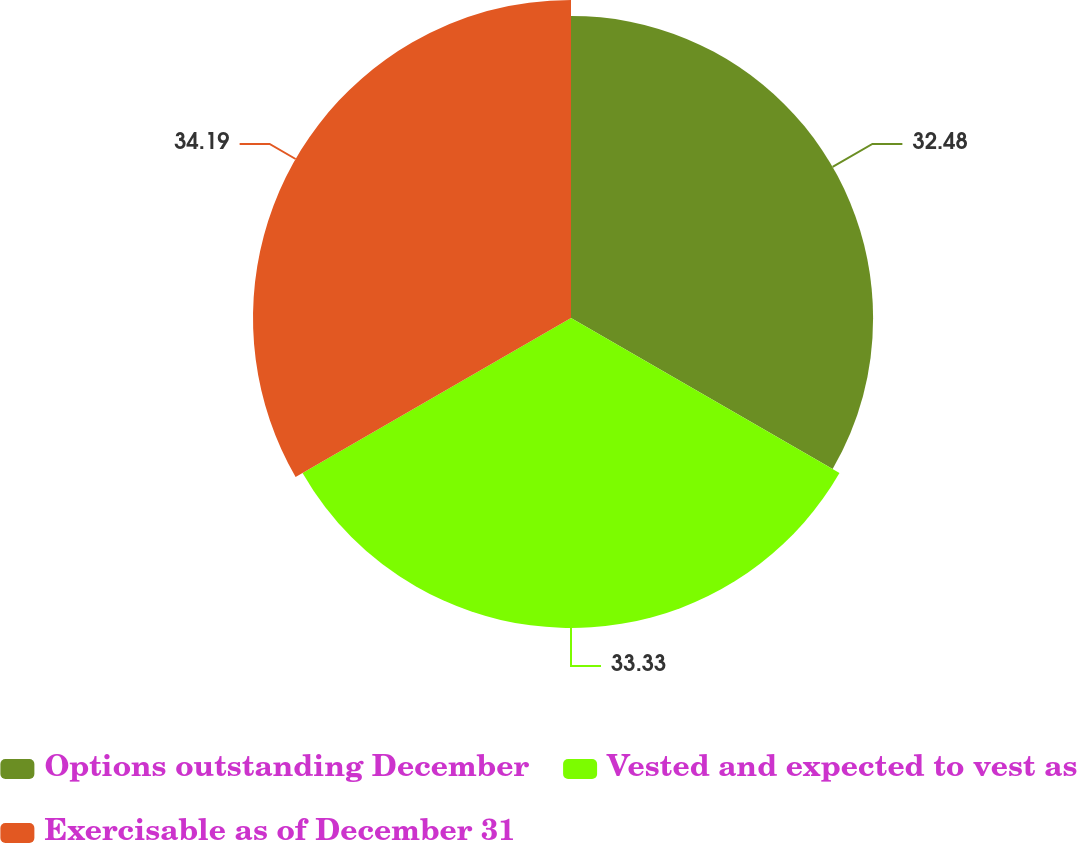<chart> <loc_0><loc_0><loc_500><loc_500><pie_chart><fcel>Options outstanding December<fcel>Vested and expected to vest as<fcel>Exercisable as of December 31<nl><fcel>32.48%<fcel>33.33%<fcel>34.19%<nl></chart> 